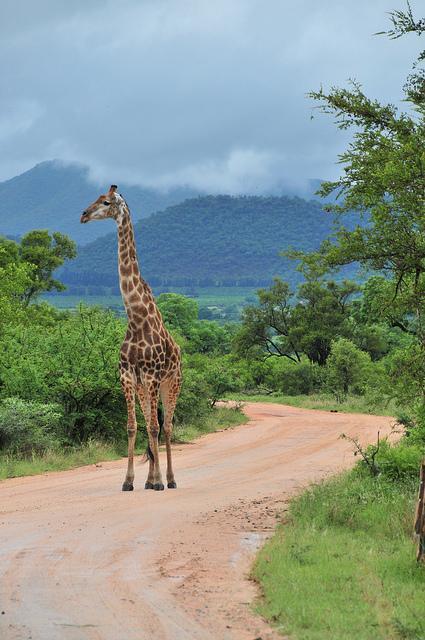How many people are seen?
Give a very brief answer. 0. 